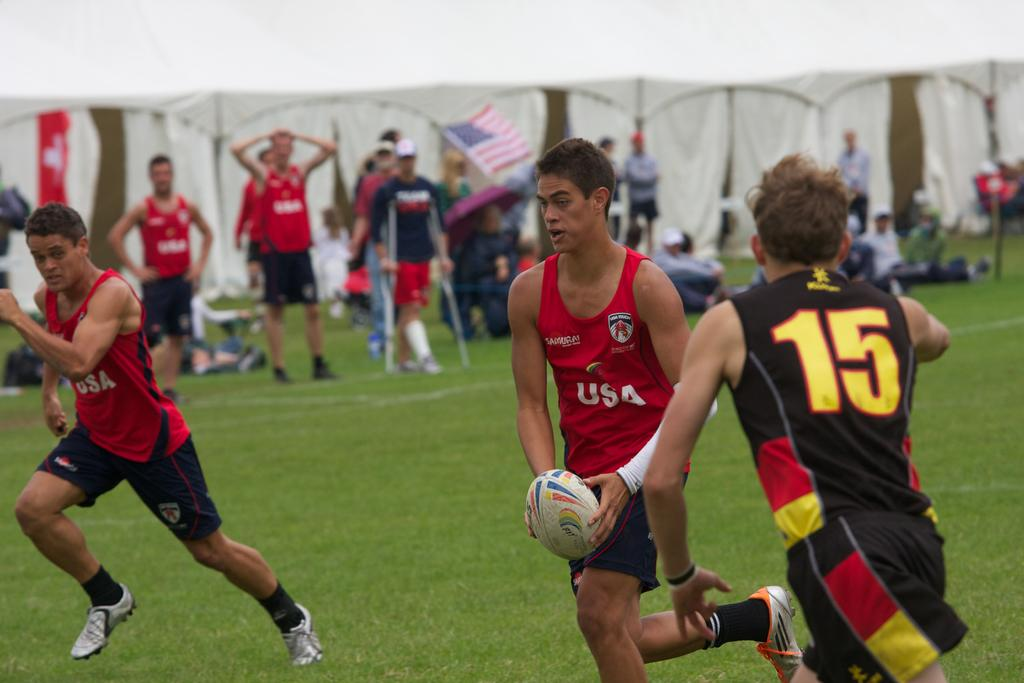What activity are the people in the foreground of the image engaged in? The people in the foreground of the image are playing a game on a ground. What can be observed about the people in the background of the image? There are people standing in the background of the image. How would you describe the appearance of the background in the image? The background appears to be blurred. What book is the person reading in the image? There is no person reading a book in the image; the people are playing a game on a ground. What type of sack is being used by the players in the game? There is no sack visible in the image; the people are playing a game without any sacks. 